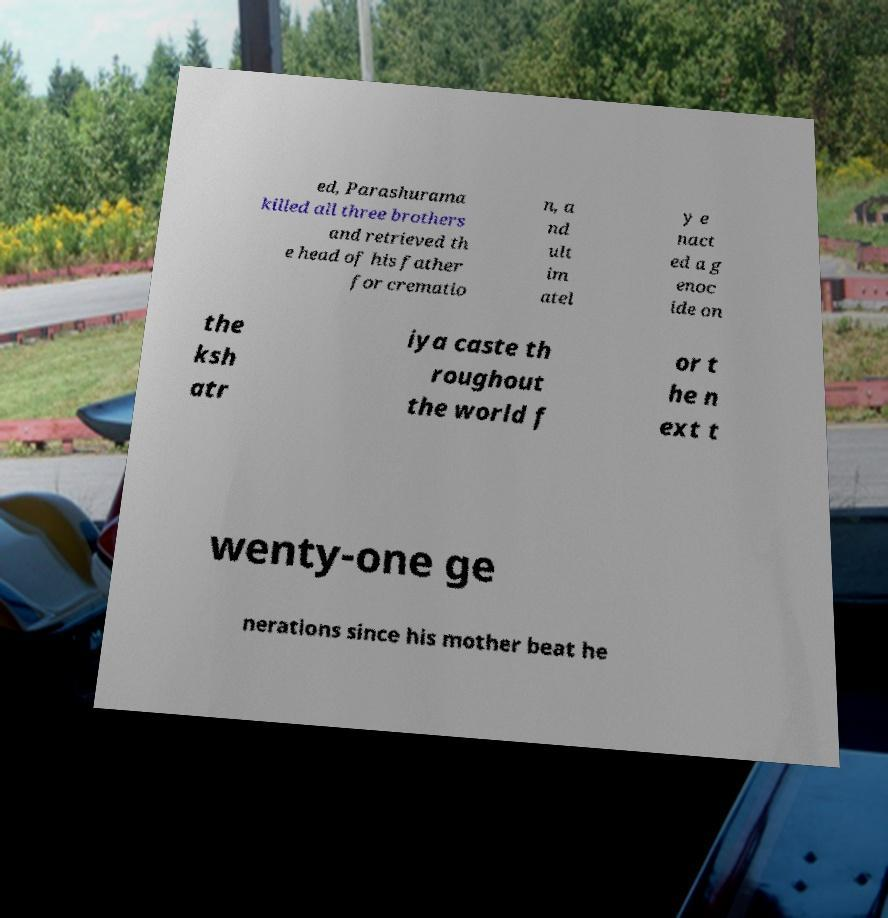Please read and relay the text visible in this image. What does it say? ed, Parashurama killed all three brothers and retrieved th e head of his father for crematio n, a nd ult im atel y e nact ed a g enoc ide on the ksh atr iya caste th roughout the world f or t he n ext t wenty-one ge nerations since his mother beat he 